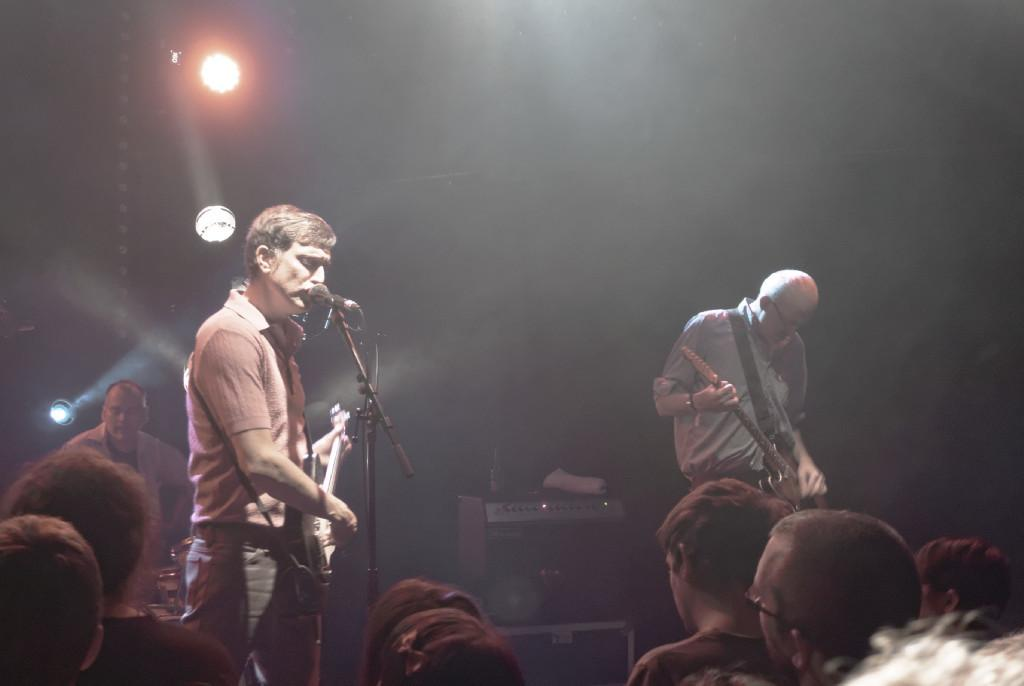What can be seen in the image that provides illumination? There are lights in the image. How would you describe the background of the image? The background of the image is blurry. What are the people in the image doing? There are persons standing in the image, and at least one person is playing a guitar. Can you identify any other people in the image? Yes, there is an audience visible in the image. How many geese are present in the image? There are no geese present in the image. What type of pain is the guitarist experiencing during the performance? There is no indication of pain in the image, and the guitarist's experience cannot be determined. 